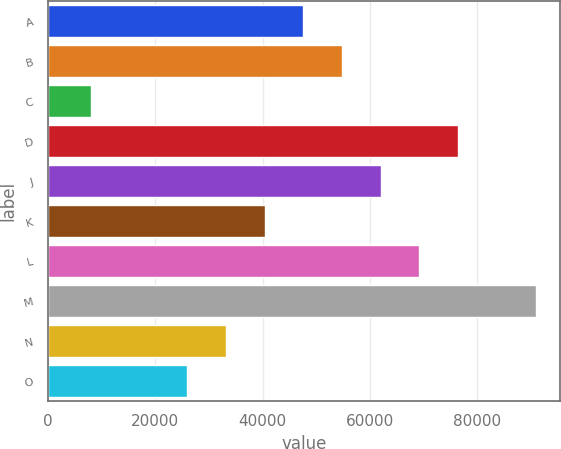<chart> <loc_0><loc_0><loc_500><loc_500><bar_chart><fcel>A<fcel>B<fcel>C<fcel>D<fcel>J<fcel>K<fcel>L<fcel>M<fcel>N<fcel>O<nl><fcel>47600<fcel>54800<fcel>8000<fcel>76400<fcel>62000<fcel>40400<fcel>69200<fcel>90800<fcel>33200<fcel>26000<nl></chart> 